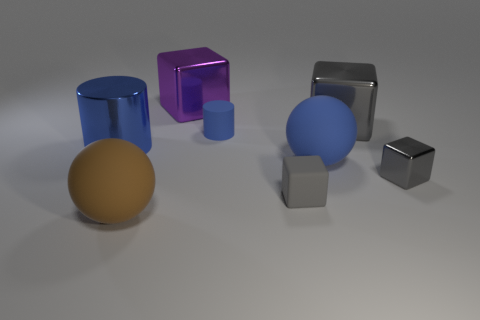Do the small rubber cube and the tiny metal object have the same color?
Give a very brief answer. Yes. What is the material of the big object that is the same color as the large cylinder?
Make the answer very short. Rubber. What material is the gray object that is the same size as the brown thing?
Make the answer very short. Metal. There is a gray metal block that is behind the gray shiny cube in front of the metal cylinder behind the brown ball; how big is it?
Make the answer very short. Large. There is a blue cylinder that is made of the same material as the big purple object; what is its size?
Keep it short and to the point. Large. There is a brown rubber sphere; is its size the same as the gray metal thing left of the small gray metal object?
Your response must be concise. Yes. What is the shape of the large rubber thing that is right of the purple metallic block?
Provide a short and direct response. Sphere. There is a matte ball in front of the gray metallic thing in front of the metal cylinder; are there any spheres to the right of it?
Make the answer very short. Yes. There is a small blue object that is the same shape as the large blue shiny thing; what material is it?
Your response must be concise. Rubber. Is there anything else that is made of the same material as the big blue cylinder?
Provide a succinct answer. Yes. 